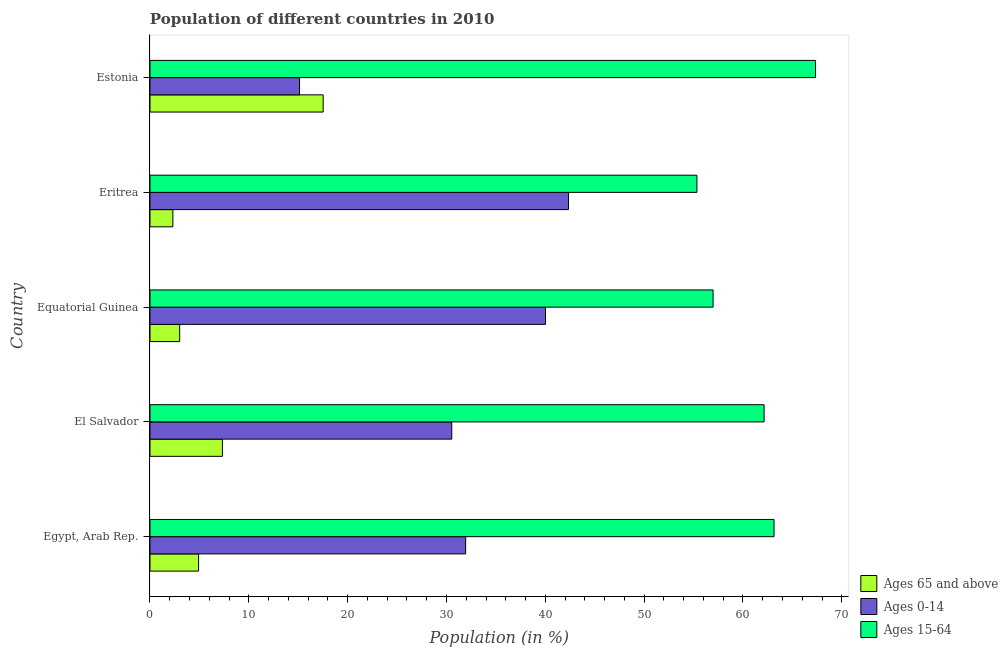How many different coloured bars are there?
Provide a succinct answer. 3. How many groups of bars are there?
Keep it short and to the point. 5. Are the number of bars per tick equal to the number of legend labels?
Keep it short and to the point. Yes. How many bars are there on the 3rd tick from the top?
Your answer should be very brief. 3. How many bars are there on the 1st tick from the bottom?
Your answer should be compact. 3. What is the label of the 3rd group of bars from the top?
Your response must be concise. Equatorial Guinea. What is the percentage of population within the age-group of 65 and above in Egypt, Arab Rep.?
Keep it short and to the point. 4.92. Across all countries, what is the maximum percentage of population within the age-group 15-64?
Give a very brief answer. 67.34. Across all countries, what is the minimum percentage of population within the age-group 15-64?
Provide a short and direct response. 55.34. In which country was the percentage of population within the age-group 15-64 maximum?
Your answer should be very brief. Estonia. In which country was the percentage of population within the age-group 15-64 minimum?
Keep it short and to the point. Eritrea. What is the total percentage of population within the age-group of 65 and above in the graph?
Your answer should be compact. 35.09. What is the difference between the percentage of population within the age-group of 65 and above in Eritrea and that in Estonia?
Give a very brief answer. -15.21. What is the difference between the percentage of population within the age-group of 65 and above in Eritrea and the percentage of population within the age-group 0-14 in Equatorial Guinea?
Ensure brevity in your answer.  -37.7. What is the average percentage of population within the age-group of 65 and above per country?
Provide a short and direct response. 7.02. What is the difference between the percentage of population within the age-group 15-64 and percentage of population within the age-group 0-14 in El Salvador?
Your answer should be very brief. 31.6. In how many countries, is the percentage of population within the age-group of 65 and above greater than 16 %?
Ensure brevity in your answer.  1. What is the ratio of the percentage of population within the age-group of 65 and above in Equatorial Guinea to that in Estonia?
Keep it short and to the point. 0.17. Is the difference between the percentage of population within the age-group 0-14 in Egypt, Arab Rep. and Eritrea greater than the difference between the percentage of population within the age-group of 65 and above in Egypt, Arab Rep. and Eritrea?
Your answer should be very brief. No. What is the difference between the highest and the second highest percentage of population within the age-group 0-14?
Offer a terse response. 2.33. What does the 1st bar from the top in Egypt, Arab Rep. represents?
Provide a succinct answer. Ages 15-64. What does the 1st bar from the bottom in El Salvador represents?
Offer a very short reply. Ages 65 and above. Is it the case that in every country, the sum of the percentage of population within the age-group of 65 and above and percentage of population within the age-group 0-14 is greater than the percentage of population within the age-group 15-64?
Offer a very short reply. No. Does the graph contain any zero values?
Offer a very short reply. No. Does the graph contain grids?
Keep it short and to the point. No. Where does the legend appear in the graph?
Offer a very short reply. Bottom right. How many legend labels are there?
Provide a succinct answer. 3. What is the title of the graph?
Keep it short and to the point. Population of different countries in 2010. Does "Hydroelectric sources" appear as one of the legend labels in the graph?
Your answer should be very brief. No. What is the label or title of the X-axis?
Provide a short and direct response. Population (in %). What is the label or title of the Y-axis?
Your answer should be very brief. Country. What is the Population (in %) in Ages 65 and above in Egypt, Arab Rep.?
Give a very brief answer. 4.92. What is the Population (in %) of Ages 0-14 in Egypt, Arab Rep.?
Offer a very short reply. 31.94. What is the Population (in %) in Ages 15-64 in Egypt, Arab Rep.?
Make the answer very short. 63.15. What is the Population (in %) in Ages 65 and above in El Salvador?
Your answer should be compact. 7.33. What is the Population (in %) of Ages 0-14 in El Salvador?
Your response must be concise. 30.53. What is the Population (in %) in Ages 15-64 in El Salvador?
Offer a terse response. 62.14. What is the Population (in %) of Ages 65 and above in Equatorial Guinea?
Provide a short and direct response. 3. What is the Population (in %) in Ages 0-14 in Equatorial Guinea?
Keep it short and to the point. 40.02. What is the Population (in %) in Ages 15-64 in Equatorial Guinea?
Provide a short and direct response. 56.98. What is the Population (in %) in Ages 65 and above in Eritrea?
Offer a terse response. 2.32. What is the Population (in %) of Ages 0-14 in Eritrea?
Provide a succinct answer. 42.35. What is the Population (in %) in Ages 15-64 in Eritrea?
Provide a short and direct response. 55.34. What is the Population (in %) of Ages 65 and above in Estonia?
Ensure brevity in your answer.  17.52. What is the Population (in %) of Ages 0-14 in Estonia?
Make the answer very short. 15.13. What is the Population (in %) of Ages 15-64 in Estonia?
Your answer should be compact. 67.34. Across all countries, what is the maximum Population (in %) in Ages 65 and above?
Your answer should be very brief. 17.52. Across all countries, what is the maximum Population (in %) of Ages 0-14?
Ensure brevity in your answer.  42.35. Across all countries, what is the maximum Population (in %) of Ages 15-64?
Ensure brevity in your answer.  67.34. Across all countries, what is the minimum Population (in %) of Ages 65 and above?
Ensure brevity in your answer.  2.32. Across all countries, what is the minimum Population (in %) of Ages 0-14?
Your response must be concise. 15.13. Across all countries, what is the minimum Population (in %) in Ages 15-64?
Your response must be concise. 55.34. What is the total Population (in %) of Ages 65 and above in the graph?
Give a very brief answer. 35.09. What is the total Population (in %) of Ages 0-14 in the graph?
Offer a terse response. 159.97. What is the total Population (in %) in Ages 15-64 in the graph?
Give a very brief answer. 304.94. What is the difference between the Population (in %) of Ages 65 and above in Egypt, Arab Rep. and that in El Salvador?
Make the answer very short. -2.41. What is the difference between the Population (in %) in Ages 0-14 in Egypt, Arab Rep. and that in El Salvador?
Offer a very short reply. 1.4. What is the difference between the Population (in %) of Ages 15-64 in Egypt, Arab Rep. and that in El Salvador?
Your answer should be compact. 1.01. What is the difference between the Population (in %) in Ages 65 and above in Egypt, Arab Rep. and that in Equatorial Guinea?
Provide a short and direct response. 1.91. What is the difference between the Population (in %) in Ages 0-14 in Egypt, Arab Rep. and that in Equatorial Guinea?
Your answer should be compact. -8.08. What is the difference between the Population (in %) in Ages 15-64 in Egypt, Arab Rep. and that in Equatorial Guinea?
Make the answer very short. 6.17. What is the difference between the Population (in %) of Ages 65 and above in Egypt, Arab Rep. and that in Eritrea?
Your response must be concise. 2.6. What is the difference between the Population (in %) of Ages 0-14 in Egypt, Arab Rep. and that in Eritrea?
Offer a very short reply. -10.41. What is the difference between the Population (in %) in Ages 15-64 in Egypt, Arab Rep. and that in Eritrea?
Offer a terse response. 7.81. What is the difference between the Population (in %) in Ages 65 and above in Egypt, Arab Rep. and that in Estonia?
Offer a terse response. -12.61. What is the difference between the Population (in %) of Ages 0-14 in Egypt, Arab Rep. and that in Estonia?
Your answer should be compact. 16.81. What is the difference between the Population (in %) of Ages 15-64 in Egypt, Arab Rep. and that in Estonia?
Provide a succinct answer. -4.2. What is the difference between the Population (in %) in Ages 65 and above in El Salvador and that in Equatorial Guinea?
Give a very brief answer. 4.32. What is the difference between the Population (in %) in Ages 0-14 in El Salvador and that in Equatorial Guinea?
Give a very brief answer. -9.48. What is the difference between the Population (in %) of Ages 15-64 in El Salvador and that in Equatorial Guinea?
Your answer should be compact. 5.16. What is the difference between the Population (in %) in Ages 65 and above in El Salvador and that in Eritrea?
Give a very brief answer. 5.01. What is the difference between the Population (in %) of Ages 0-14 in El Salvador and that in Eritrea?
Ensure brevity in your answer.  -11.81. What is the difference between the Population (in %) of Ages 15-64 in El Salvador and that in Eritrea?
Ensure brevity in your answer.  6.8. What is the difference between the Population (in %) in Ages 65 and above in El Salvador and that in Estonia?
Make the answer very short. -10.2. What is the difference between the Population (in %) of Ages 0-14 in El Salvador and that in Estonia?
Offer a terse response. 15.4. What is the difference between the Population (in %) of Ages 15-64 in El Salvador and that in Estonia?
Ensure brevity in your answer.  -5.2. What is the difference between the Population (in %) in Ages 65 and above in Equatorial Guinea and that in Eritrea?
Give a very brief answer. 0.69. What is the difference between the Population (in %) of Ages 0-14 in Equatorial Guinea and that in Eritrea?
Your answer should be compact. -2.33. What is the difference between the Population (in %) of Ages 15-64 in Equatorial Guinea and that in Eritrea?
Your answer should be very brief. 1.64. What is the difference between the Population (in %) in Ages 65 and above in Equatorial Guinea and that in Estonia?
Ensure brevity in your answer.  -14.52. What is the difference between the Population (in %) of Ages 0-14 in Equatorial Guinea and that in Estonia?
Provide a succinct answer. 24.89. What is the difference between the Population (in %) of Ages 15-64 in Equatorial Guinea and that in Estonia?
Provide a succinct answer. -10.37. What is the difference between the Population (in %) of Ages 65 and above in Eritrea and that in Estonia?
Give a very brief answer. -15.21. What is the difference between the Population (in %) of Ages 0-14 in Eritrea and that in Estonia?
Ensure brevity in your answer.  27.21. What is the difference between the Population (in %) in Ages 15-64 in Eritrea and that in Estonia?
Make the answer very short. -12. What is the difference between the Population (in %) in Ages 65 and above in Egypt, Arab Rep. and the Population (in %) in Ages 0-14 in El Salvador?
Your response must be concise. -25.62. What is the difference between the Population (in %) of Ages 65 and above in Egypt, Arab Rep. and the Population (in %) of Ages 15-64 in El Salvador?
Your answer should be compact. -57.22. What is the difference between the Population (in %) of Ages 0-14 in Egypt, Arab Rep. and the Population (in %) of Ages 15-64 in El Salvador?
Provide a short and direct response. -30.2. What is the difference between the Population (in %) in Ages 65 and above in Egypt, Arab Rep. and the Population (in %) in Ages 0-14 in Equatorial Guinea?
Your answer should be very brief. -35.1. What is the difference between the Population (in %) of Ages 65 and above in Egypt, Arab Rep. and the Population (in %) of Ages 15-64 in Equatorial Guinea?
Give a very brief answer. -52.06. What is the difference between the Population (in %) in Ages 0-14 in Egypt, Arab Rep. and the Population (in %) in Ages 15-64 in Equatorial Guinea?
Provide a short and direct response. -25.04. What is the difference between the Population (in %) of Ages 65 and above in Egypt, Arab Rep. and the Population (in %) of Ages 0-14 in Eritrea?
Make the answer very short. -37.43. What is the difference between the Population (in %) in Ages 65 and above in Egypt, Arab Rep. and the Population (in %) in Ages 15-64 in Eritrea?
Ensure brevity in your answer.  -50.42. What is the difference between the Population (in %) of Ages 0-14 in Egypt, Arab Rep. and the Population (in %) of Ages 15-64 in Eritrea?
Your response must be concise. -23.4. What is the difference between the Population (in %) in Ages 65 and above in Egypt, Arab Rep. and the Population (in %) in Ages 0-14 in Estonia?
Your answer should be compact. -10.22. What is the difference between the Population (in %) of Ages 65 and above in Egypt, Arab Rep. and the Population (in %) of Ages 15-64 in Estonia?
Your response must be concise. -62.43. What is the difference between the Population (in %) of Ages 0-14 in Egypt, Arab Rep. and the Population (in %) of Ages 15-64 in Estonia?
Ensure brevity in your answer.  -35.4. What is the difference between the Population (in %) of Ages 65 and above in El Salvador and the Population (in %) of Ages 0-14 in Equatorial Guinea?
Offer a very short reply. -32.69. What is the difference between the Population (in %) of Ages 65 and above in El Salvador and the Population (in %) of Ages 15-64 in Equatorial Guinea?
Your answer should be compact. -49.65. What is the difference between the Population (in %) in Ages 0-14 in El Salvador and the Population (in %) in Ages 15-64 in Equatorial Guinea?
Ensure brevity in your answer.  -26.44. What is the difference between the Population (in %) in Ages 65 and above in El Salvador and the Population (in %) in Ages 0-14 in Eritrea?
Provide a short and direct response. -35.02. What is the difference between the Population (in %) in Ages 65 and above in El Salvador and the Population (in %) in Ages 15-64 in Eritrea?
Your answer should be compact. -48.01. What is the difference between the Population (in %) in Ages 0-14 in El Salvador and the Population (in %) in Ages 15-64 in Eritrea?
Offer a very short reply. -24.8. What is the difference between the Population (in %) of Ages 65 and above in El Salvador and the Population (in %) of Ages 0-14 in Estonia?
Offer a terse response. -7.81. What is the difference between the Population (in %) of Ages 65 and above in El Salvador and the Population (in %) of Ages 15-64 in Estonia?
Make the answer very short. -60.02. What is the difference between the Population (in %) of Ages 0-14 in El Salvador and the Population (in %) of Ages 15-64 in Estonia?
Keep it short and to the point. -36.81. What is the difference between the Population (in %) in Ages 65 and above in Equatorial Guinea and the Population (in %) in Ages 0-14 in Eritrea?
Your answer should be very brief. -39.34. What is the difference between the Population (in %) in Ages 65 and above in Equatorial Guinea and the Population (in %) in Ages 15-64 in Eritrea?
Make the answer very short. -52.34. What is the difference between the Population (in %) in Ages 0-14 in Equatorial Guinea and the Population (in %) in Ages 15-64 in Eritrea?
Ensure brevity in your answer.  -15.32. What is the difference between the Population (in %) in Ages 65 and above in Equatorial Guinea and the Population (in %) in Ages 0-14 in Estonia?
Give a very brief answer. -12.13. What is the difference between the Population (in %) in Ages 65 and above in Equatorial Guinea and the Population (in %) in Ages 15-64 in Estonia?
Keep it short and to the point. -64.34. What is the difference between the Population (in %) of Ages 0-14 in Equatorial Guinea and the Population (in %) of Ages 15-64 in Estonia?
Offer a terse response. -27.32. What is the difference between the Population (in %) of Ages 65 and above in Eritrea and the Population (in %) of Ages 0-14 in Estonia?
Provide a succinct answer. -12.82. What is the difference between the Population (in %) in Ages 65 and above in Eritrea and the Population (in %) in Ages 15-64 in Estonia?
Offer a very short reply. -65.03. What is the difference between the Population (in %) of Ages 0-14 in Eritrea and the Population (in %) of Ages 15-64 in Estonia?
Your response must be concise. -25. What is the average Population (in %) in Ages 65 and above per country?
Your answer should be compact. 7.02. What is the average Population (in %) of Ages 0-14 per country?
Offer a very short reply. 31.99. What is the average Population (in %) of Ages 15-64 per country?
Offer a terse response. 60.99. What is the difference between the Population (in %) in Ages 65 and above and Population (in %) in Ages 0-14 in Egypt, Arab Rep.?
Offer a very short reply. -27.02. What is the difference between the Population (in %) in Ages 65 and above and Population (in %) in Ages 15-64 in Egypt, Arab Rep.?
Provide a short and direct response. -58.23. What is the difference between the Population (in %) of Ages 0-14 and Population (in %) of Ages 15-64 in Egypt, Arab Rep.?
Ensure brevity in your answer.  -31.21. What is the difference between the Population (in %) in Ages 65 and above and Population (in %) in Ages 0-14 in El Salvador?
Offer a very short reply. -23.21. What is the difference between the Population (in %) in Ages 65 and above and Population (in %) in Ages 15-64 in El Salvador?
Your answer should be very brief. -54.81. What is the difference between the Population (in %) in Ages 0-14 and Population (in %) in Ages 15-64 in El Salvador?
Offer a terse response. -31.6. What is the difference between the Population (in %) in Ages 65 and above and Population (in %) in Ages 0-14 in Equatorial Guinea?
Your response must be concise. -37.02. What is the difference between the Population (in %) in Ages 65 and above and Population (in %) in Ages 15-64 in Equatorial Guinea?
Make the answer very short. -53.97. What is the difference between the Population (in %) in Ages 0-14 and Population (in %) in Ages 15-64 in Equatorial Guinea?
Your answer should be very brief. -16.96. What is the difference between the Population (in %) of Ages 65 and above and Population (in %) of Ages 0-14 in Eritrea?
Provide a succinct answer. -40.03. What is the difference between the Population (in %) in Ages 65 and above and Population (in %) in Ages 15-64 in Eritrea?
Provide a short and direct response. -53.02. What is the difference between the Population (in %) in Ages 0-14 and Population (in %) in Ages 15-64 in Eritrea?
Offer a terse response. -12.99. What is the difference between the Population (in %) in Ages 65 and above and Population (in %) in Ages 0-14 in Estonia?
Offer a terse response. 2.39. What is the difference between the Population (in %) in Ages 65 and above and Population (in %) in Ages 15-64 in Estonia?
Your response must be concise. -49.82. What is the difference between the Population (in %) of Ages 0-14 and Population (in %) of Ages 15-64 in Estonia?
Your response must be concise. -52.21. What is the ratio of the Population (in %) of Ages 65 and above in Egypt, Arab Rep. to that in El Salvador?
Make the answer very short. 0.67. What is the ratio of the Population (in %) in Ages 0-14 in Egypt, Arab Rep. to that in El Salvador?
Keep it short and to the point. 1.05. What is the ratio of the Population (in %) of Ages 15-64 in Egypt, Arab Rep. to that in El Salvador?
Make the answer very short. 1.02. What is the ratio of the Population (in %) of Ages 65 and above in Egypt, Arab Rep. to that in Equatorial Guinea?
Offer a very short reply. 1.64. What is the ratio of the Population (in %) of Ages 0-14 in Egypt, Arab Rep. to that in Equatorial Guinea?
Keep it short and to the point. 0.8. What is the ratio of the Population (in %) of Ages 15-64 in Egypt, Arab Rep. to that in Equatorial Guinea?
Keep it short and to the point. 1.11. What is the ratio of the Population (in %) of Ages 65 and above in Egypt, Arab Rep. to that in Eritrea?
Ensure brevity in your answer.  2.12. What is the ratio of the Population (in %) of Ages 0-14 in Egypt, Arab Rep. to that in Eritrea?
Offer a very short reply. 0.75. What is the ratio of the Population (in %) in Ages 15-64 in Egypt, Arab Rep. to that in Eritrea?
Your answer should be compact. 1.14. What is the ratio of the Population (in %) of Ages 65 and above in Egypt, Arab Rep. to that in Estonia?
Ensure brevity in your answer.  0.28. What is the ratio of the Population (in %) in Ages 0-14 in Egypt, Arab Rep. to that in Estonia?
Your response must be concise. 2.11. What is the ratio of the Population (in %) of Ages 15-64 in Egypt, Arab Rep. to that in Estonia?
Keep it short and to the point. 0.94. What is the ratio of the Population (in %) of Ages 65 and above in El Salvador to that in Equatorial Guinea?
Keep it short and to the point. 2.44. What is the ratio of the Population (in %) in Ages 0-14 in El Salvador to that in Equatorial Guinea?
Give a very brief answer. 0.76. What is the ratio of the Population (in %) in Ages 15-64 in El Salvador to that in Equatorial Guinea?
Offer a very short reply. 1.09. What is the ratio of the Population (in %) in Ages 65 and above in El Salvador to that in Eritrea?
Provide a short and direct response. 3.16. What is the ratio of the Population (in %) of Ages 0-14 in El Salvador to that in Eritrea?
Provide a succinct answer. 0.72. What is the ratio of the Population (in %) of Ages 15-64 in El Salvador to that in Eritrea?
Ensure brevity in your answer.  1.12. What is the ratio of the Population (in %) of Ages 65 and above in El Salvador to that in Estonia?
Make the answer very short. 0.42. What is the ratio of the Population (in %) of Ages 0-14 in El Salvador to that in Estonia?
Make the answer very short. 2.02. What is the ratio of the Population (in %) of Ages 15-64 in El Salvador to that in Estonia?
Offer a very short reply. 0.92. What is the ratio of the Population (in %) of Ages 65 and above in Equatorial Guinea to that in Eritrea?
Offer a very short reply. 1.3. What is the ratio of the Population (in %) in Ages 0-14 in Equatorial Guinea to that in Eritrea?
Keep it short and to the point. 0.95. What is the ratio of the Population (in %) of Ages 15-64 in Equatorial Guinea to that in Eritrea?
Offer a terse response. 1.03. What is the ratio of the Population (in %) of Ages 65 and above in Equatorial Guinea to that in Estonia?
Provide a succinct answer. 0.17. What is the ratio of the Population (in %) in Ages 0-14 in Equatorial Guinea to that in Estonia?
Offer a terse response. 2.64. What is the ratio of the Population (in %) of Ages 15-64 in Equatorial Guinea to that in Estonia?
Your answer should be very brief. 0.85. What is the ratio of the Population (in %) in Ages 65 and above in Eritrea to that in Estonia?
Provide a short and direct response. 0.13. What is the ratio of the Population (in %) of Ages 0-14 in Eritrea to that in Estonia?
Provide a short and direct response. 2.8. What is the ratio of the Population (in %) of Ages 15-64 in Eritrea to that in Estonia?
Make the answer very short. 0.82. What is the difference between the highest and the second highest Population (in %) in Ages 65 and above?
Ensure brevity in your answer.  10.2. What is the difference between the highest and the second highest Population (in %) in Ages 0-14?
Make the answer very short. 2.33. What is the difference between the highest and the second highest Population (in %) in Ages 15-64?
Offer a very short reply. 4.2. What is the difference between the highest and the lowest Population (in %) in Ages 65 and above?
Keep it short and to the point. 15.21. What is the difference between the highest and the lowest Population (in %) in Ages 0-14?
Offer a very short reply. 27.21. What is the difference between the highest and the lowest Population (in %) in Ages 15-64?
Your answer should be compact. 12. 